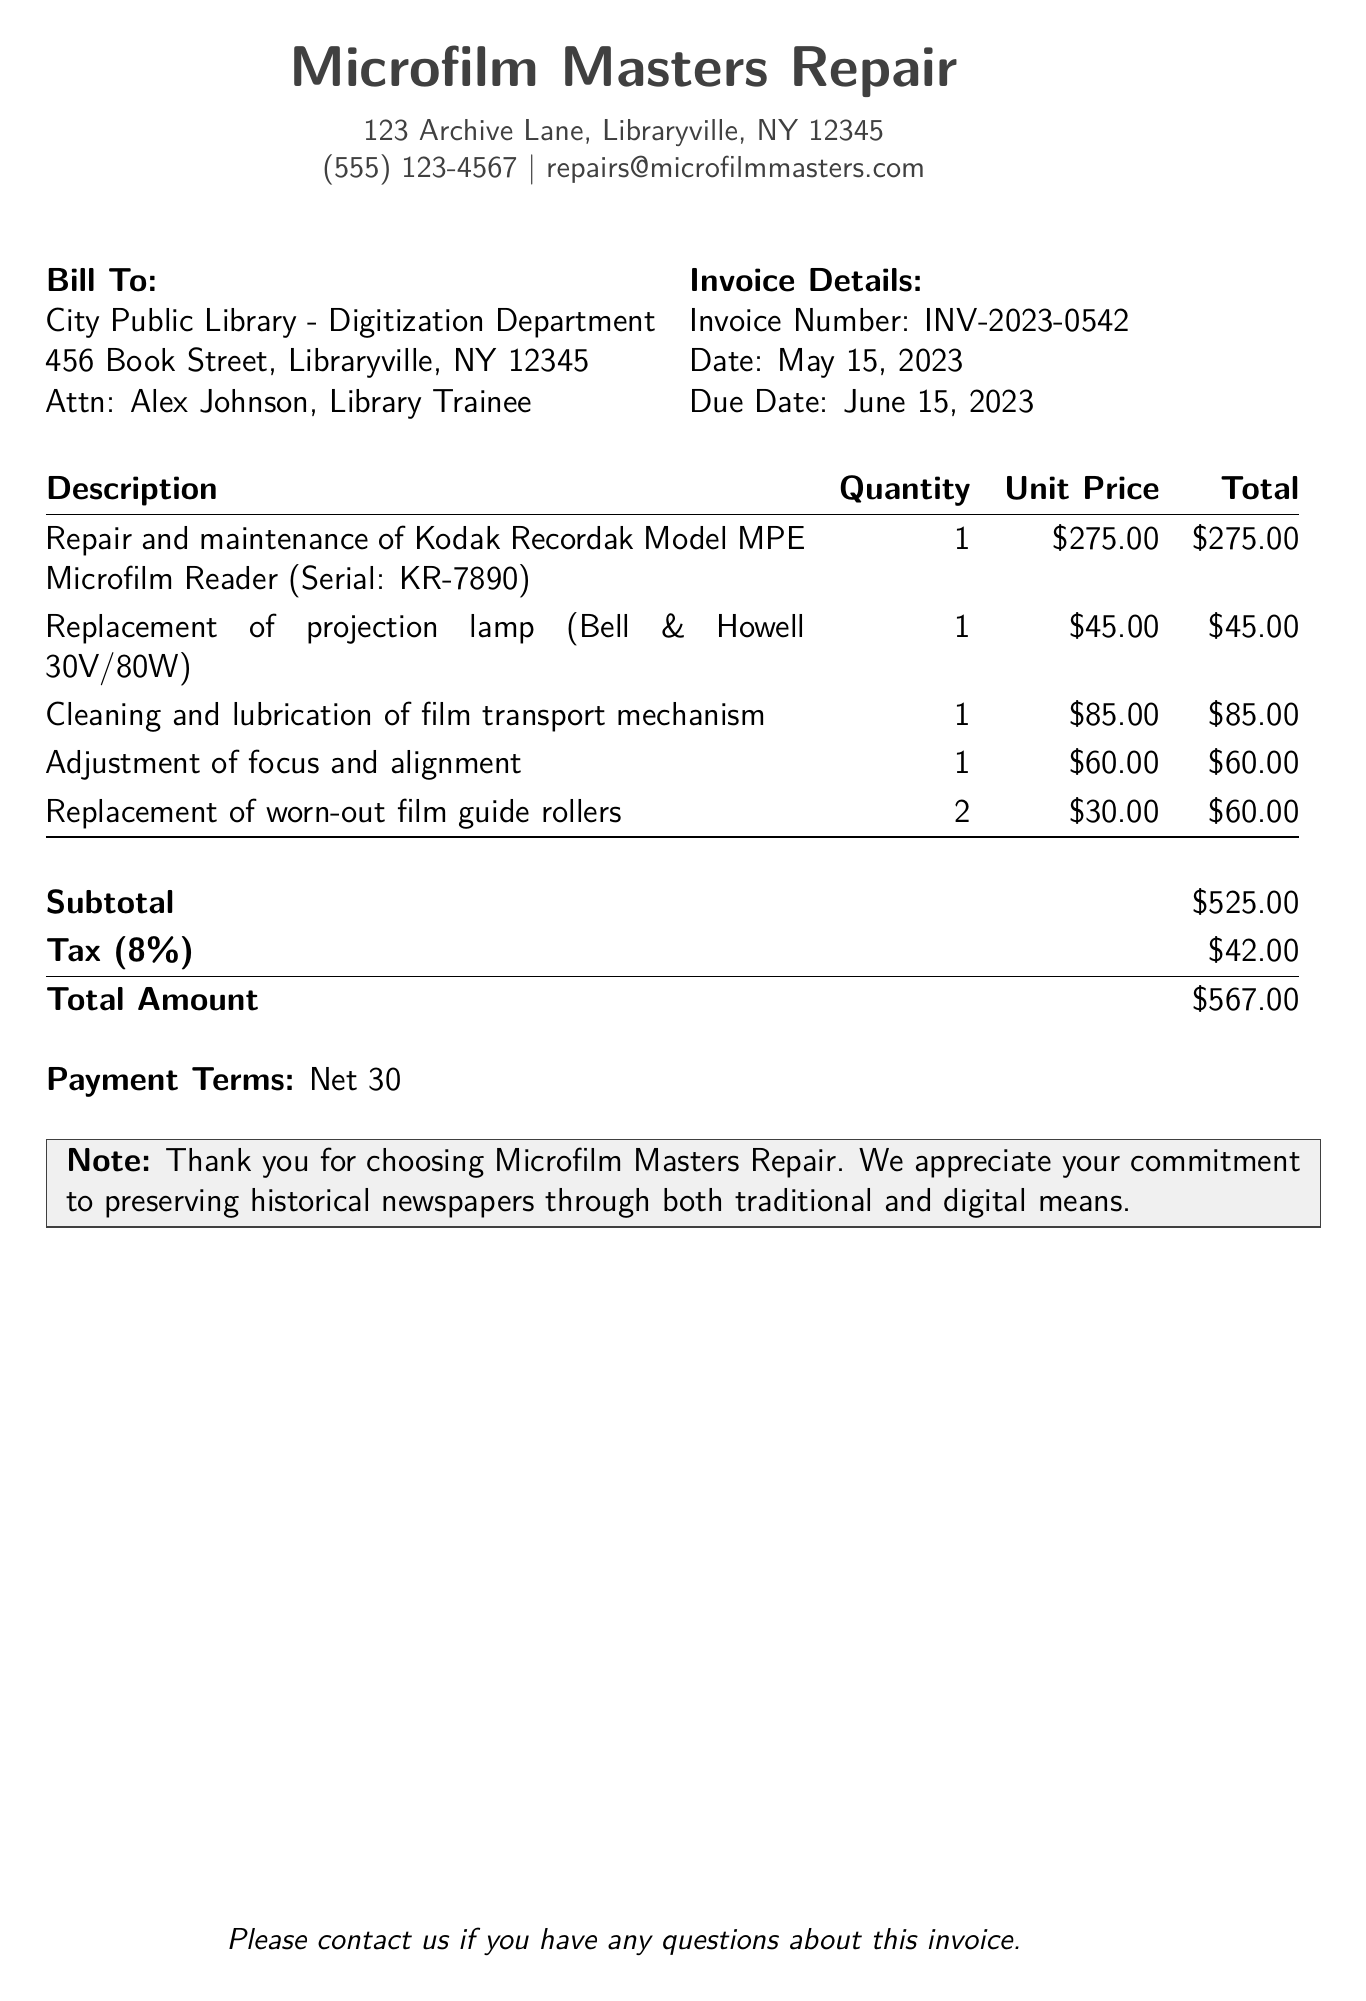What is the invoice number? The invoice number is a unique identifier for the bill, located in the invoice details section of the document.
Answer: INV-2023-0542 What is the date of the invoice? The date indicates when the invoice was issued and is found in the invoice details section.
Answer: May 15, 2023 How much is the subtotal before tax? The subtotal is the sum of all item charges before tax, listed at the end of the itemization.
Answer: $525.00 What is the total amount due? The total amount due is the final charge including taxes, found in the summary section.
Answer: $567.00 What is the tax rate applied to the invoice? The tax rate provides information on the percentage of tax calculated on the subtotal, indicated in the summary section.
Answer: 8% Who is the contact person for the bill? The contact person’s name is the individual identified in the bill to section.
Answer: Alex Johnson What services were rendered for the Kodak Recordak Model MPE? This refers to the specific services provided for this microfilm reader listed in the item description.
Answer: Repair and maintenance What is the payment term stated in the document? The payment term indicates the period allowed for payment, which is specified in the invoice.
Answer: Net 30 How many worn-out film guide rollers were replaced? The quantity of specific items needs to be referenced in the itemization for completion.
Answer: 2 